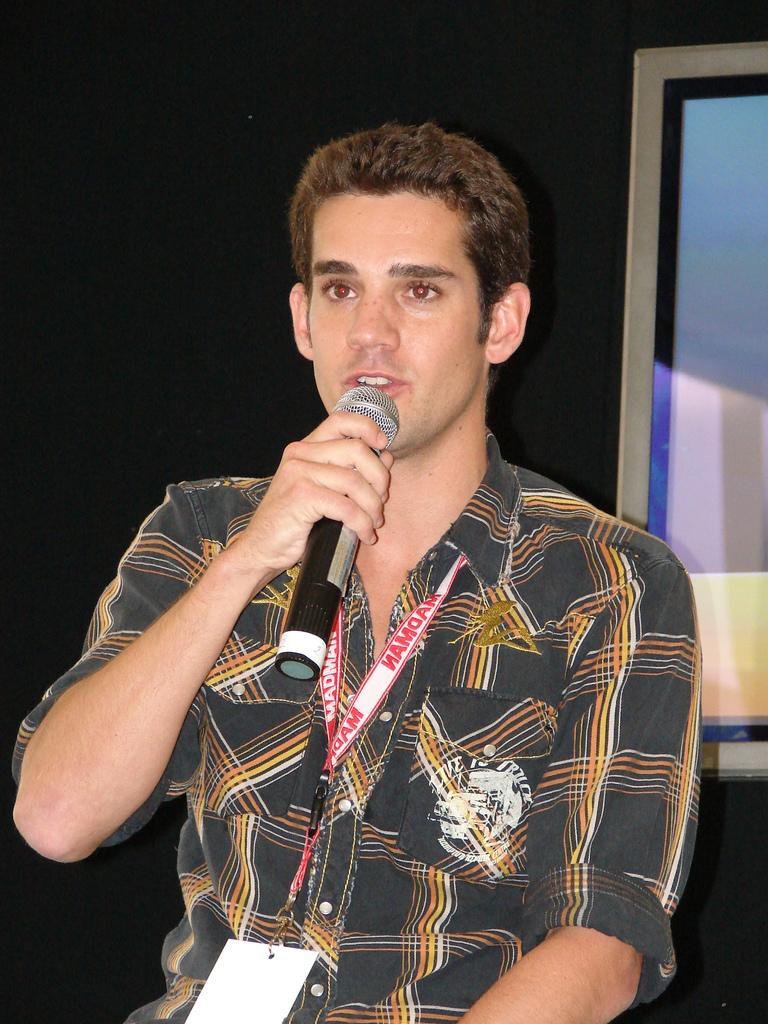Could you give a brief overview of what you see in this image? In this image, we can see a person wearing an ID card and holding a mic with his hand. There is a photo frame on the right side of the image. 